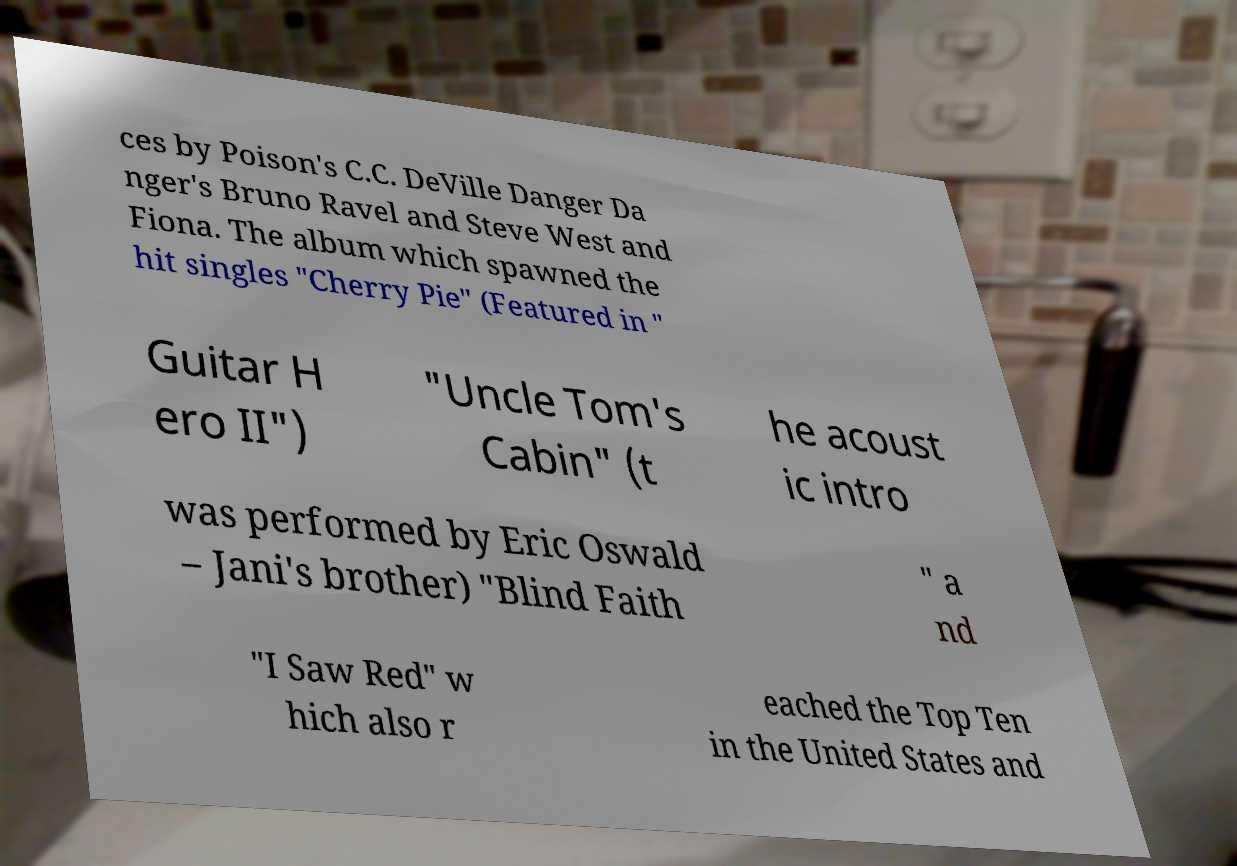Can you read and provide the text displayed in the image?This photo seems to have some interesting text. Can you extract and type it out for me? ces by Poison's C.C. DeVille Danger Da nger's Bruno Ravel and Steve West and Fiona. The album which spawned the hit singles "Cherry Pie" (Featured in " Guitar H ero II") "Uncle Tom's Cabin" (t he acoust ic intro was performed by Eric Oswald – Jani's brother) "Blind Faith " a nd "I Saw Red" w hich also r eached the Top Ten in the United States and 